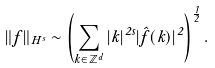Convert formula to latex. <formula><loc_0><loc_0><loc_500><loc_500>\| f \| _ { H ^ { s } } \sim \left ( \sum _ { k \in \mathbb { Z } ^ { d } } | k | ^ { 2 s } | \hat { f } ( k ) | ^ { 2 } \right ) ^ { \frac { 1 } { 2 } } .</formula> 